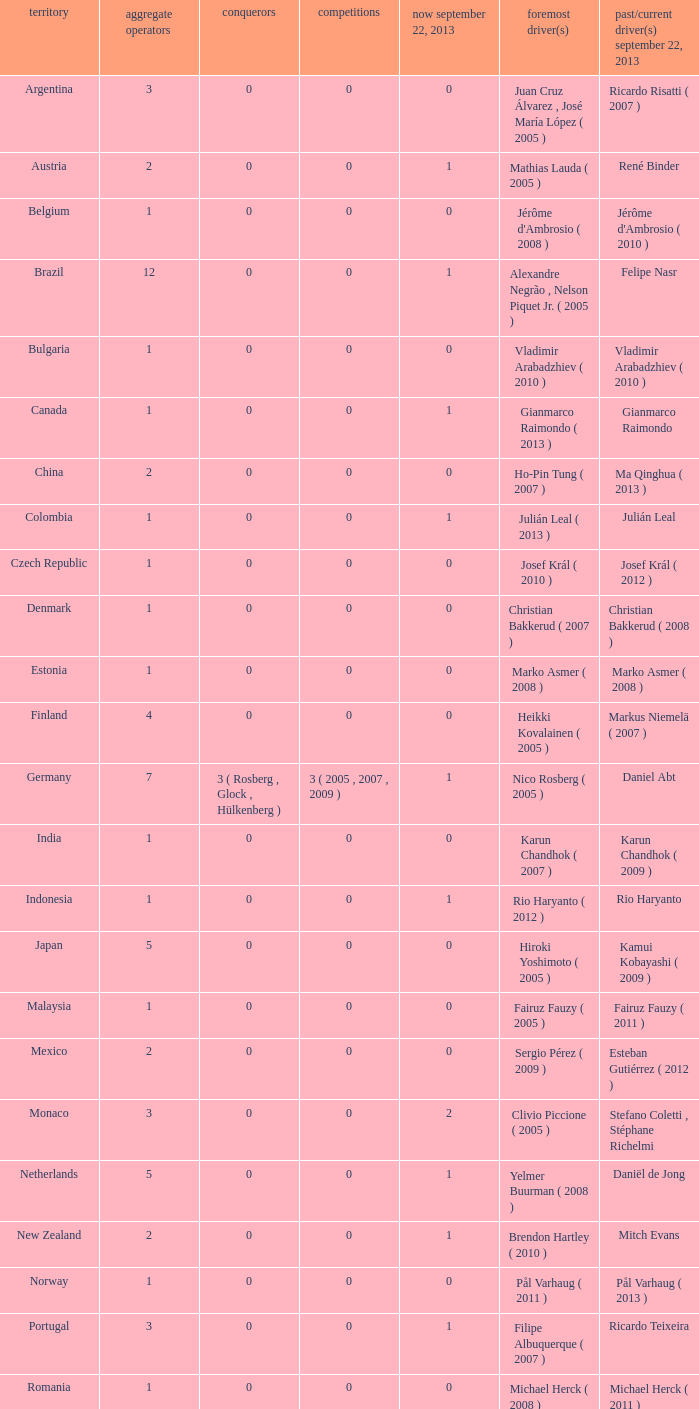Can you give me this table as a dict? {'header': ['territory', 'aggregate operators', 'conquerors', 'competitions', 'now september 22, 2013', 'foremost driver(s)', 'past/current driver(s) september 22, 2013'], 'rows': [['Argentina', '3', '0', '0', '0', 'Juan Cruz Álvarez , José María López ( 2005 )', 'Ricardo Risatti ( 2007 )'], ['Austria', '2', '0', '0', '1', 'Mathias Lauda ( 2005 )', 'René Binder'], ['Belgium', '1', '0', '0', '0', "Jérôme d'Ambrosio ( 2008 )", "Jérôme d'Ambrosio ( 2010 )"], ['Brazil', '12', '0', '0', '1', 'Alexandre Negrão , Nelson Piquet Jr. ( 2005 )', 'Felipe Nasr'], ['Bulgaria', '1', '0', '0', '0', 'Vladimir Arabadzhiev ( 2010 )', 'Vladimir Arabadzhiev ( 2010 )'], ['Canada', '1', '0', '0', '1', 'Gianmarco Raimondo ( 2013 )', 'Gianmarco Raimondo'], ['China', '2', '0', '0', '0', 'Ho-Pin Tung ( 2007 )', 'Ma Qinghua ( 2013 )'], ['Colombia', '1', '0', '0', '1', 'Julián Leal ( 2013 )', 'Julián Leal'], ['Czech Republic', '1', '0', '0', '0', 'Josef Král ( 2010 )', 'Josef Král ( 2012 )'], ['Denmark', '1', '0', '0', '0', 'Christian Bakkerud ( 2007 )', 'Christian Bakkerud ( 2008 )'], ['Estonia', '1', '0', '0', '0', 'Marko Asmer ( 2008 )', 'Marko Asmer ( 2008 )'], ['Finland', '4', '0', '0', '0', 'Heikki Kovalainen ( 2005 )', 'Markus Niemelä ( 2007 )'], ['Germany', '7', '3 ( Rosberg , Glock , Hülkenberg )', '3 ( 2005 , 2007 , 2009 )', '1', 'Nico Rosberg ( 2005 )', 'Daniel Abt'], ['India', '1', '0', '0', '0', 'Karun Chandhok ( 2007 )', 'Karun Chandhok ( 2009 )'], ['Indonesia', '1', '0', '0', '1', 'Rio Haryanto ( 2012 )', 'Rio Haryanto'], ['Japan', '5', '0', '0', '0', 'Hiroki Yoshimoto ( 2005 )', 'Kamui Kobayashi ( 2009 )'], ['Malaysia', '1', '0', '0', '0', 'Fairuz Fauzy ( 2005 )', 'Fairuz Fauzy ( 2011 )'], ['Mexico', '2', '0', '0', '0', 'Sergio Pérez ( 2009 )', 'Esteban Gutiérrez ( 2012 )'], ['Monaco', '3', '0', '0', '2', 'Clivio Piccione ( 2005 )', 'Stefano Coletti , Stéphane Richelmi'], ['Netherlands', '5', '0', '0', '1', 'Yelmer Buurman ( 2008 )', 'Daniël de Jong'], ['New Zealand', '2', '0', '0', '1', 'Brendon Hartley ( 2010 )', 'Mitch Evans'], ['Norway', '1', '0', '0', '0', 'Pål Varhaug ( 2011 )', 'Pål Varhaug ( 2013 )'], ['Portugal', '3', '0', '0', '1', 'Filipe Albuquerque ( 2007 )', 'Ricardo Teixeira'], ['Romania', '1', '0', '0', '0', 'Michael Herck ( 2008 )', 'Michael Herck ( 2011 )'], ['Russia', '2', '0', '0', '0', 'Vitaly Petrov ( 2006 )', 'Mikhail Aleshin ( 2011 )'], ['Serbia', '1', '0', '0', '0', 'Miloš Pavlović ( 2008 )', 'Miloš Pavlović ( 2008 )'], ['South Africa', '1', '0', '0', '0', 'Adrian Zaugg ( 2007 )', 'Adrian Zaugg ( 2010 )'], ['Spain', '10', '0', '0', '2', 'Borja García , Sergio Hernández ( 2005 )', 'Sergio Canamasas , Dani Clos'], ['Sweden', '1', '0', '0', '1', 'Marcus Ericsson ( 2010 )', 'Marcus Ericsson'], ['Switzerland', '5', '0', '0', '2', 'Neel Jani ( 2005 )', 'Fabio Leimer , Simon Trummer'], ['Turkey', '2', '0', '0', '0', 'Can Artam ( 2005 )', 'Jason Tahincioglu ( 2007 )'], ['United Arab Emirates', '1', '0', '0', '0', 'Andreas Zuber ( 2006 )', 'Andreas Zuber ( 2009 )'], ['United States', '4', '0', '0', '2', 'Scott Speed ( 2005 )', 'Jake Rosenzweig , Alexander Rossi']]} How many entries are there for first driver for Canada? 1.0. 